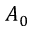<formula> <loc_0><loc_0><loc_500><loc_500>A _ { 0 }</formula> 